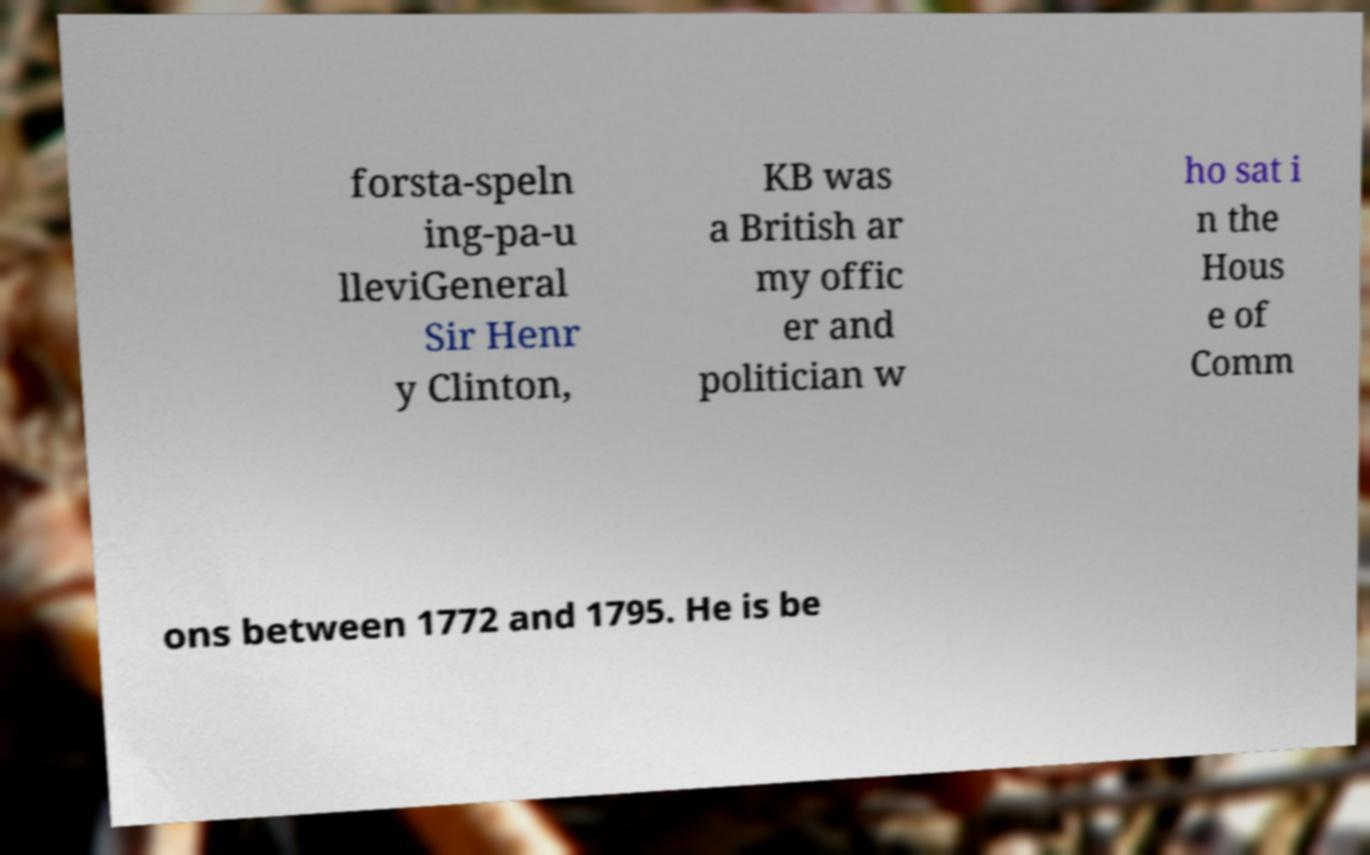For documentation purposes, I need the text within this image transcribed. Could you provide that? forsta-speln ing-pa-u lleviGeneral Sir Henr y Clinton, KB was a British ar my offic er and politician w ho sat i n the Hous e of Comm ons between 1772 and 1795. He is be 